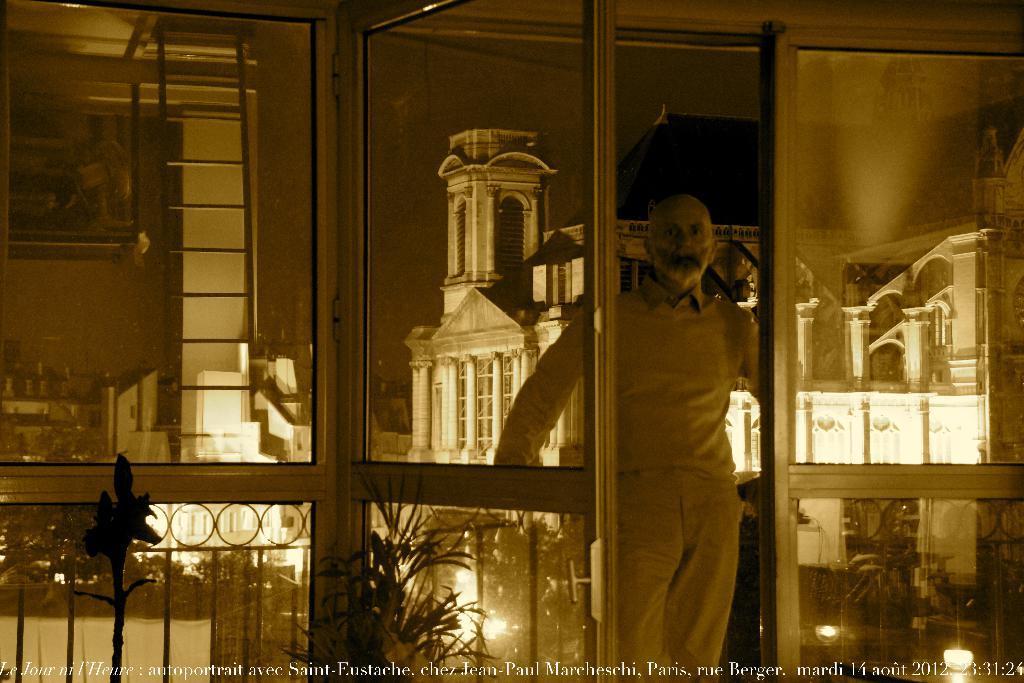Could you give a brief overview of what you see in this image? In this image we can see a person, there are windows, a door, there is a photo frame on the wall, there are house plants, also we can see the reflection of buildings on the window mirror. 